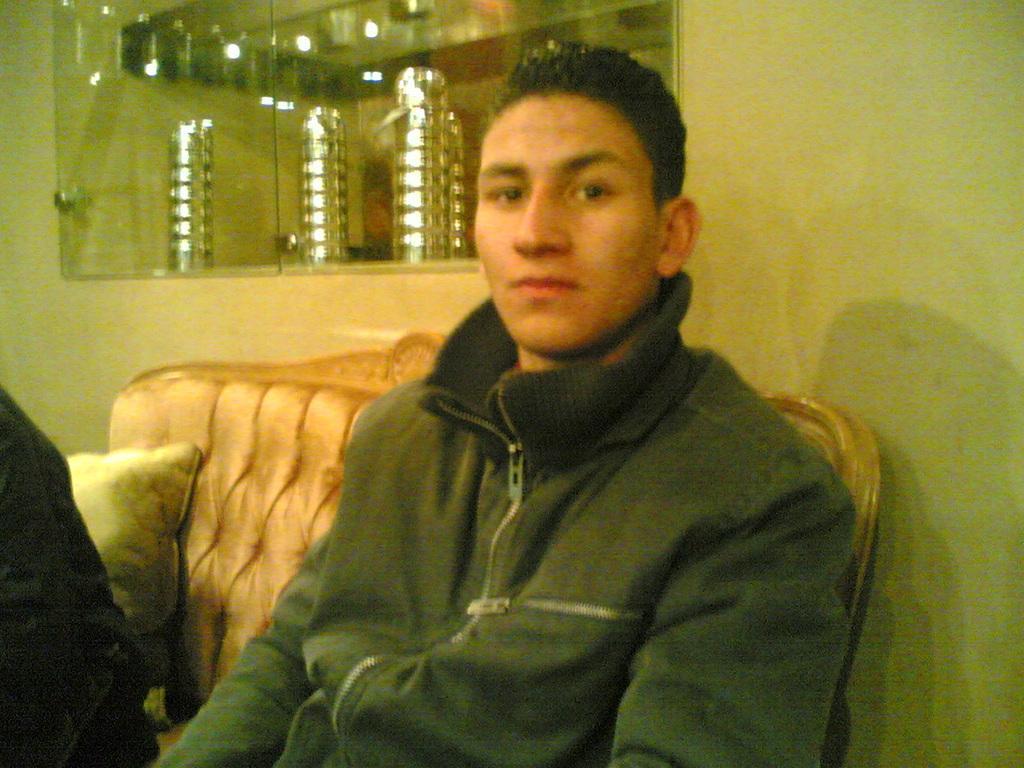Describe this image in one or two sentences. In this picture there is a boy in the center of the image on a sofa and there is a show case at the top side of the image, there is another man on the left side of the image. 